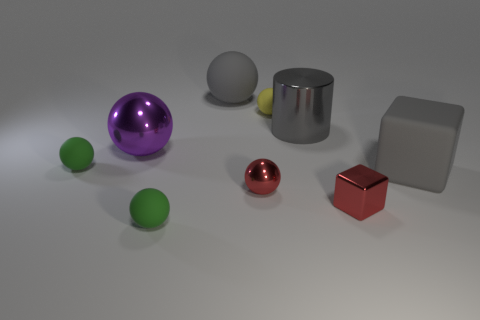There is a block that is the same color as the small metallic ball; what material is it?
Give a very brief answer. Metal. The matte sphere that is the same color as the metallic cylinder is what size?
Ensure brevity in your answer.  Large. Is the color of the tiny block the same as the rubber block?
Make the answer very short. No. What material is the gray object that is to the left of the red thing that is on the left side of the small red block?
Make the answer very short. Rubber. What size is the red sphere?
Give a very brief answer. Small. There is a gray cube that is the same material as the yellow thing; what size is it?
Offer a very short reply. Large. Is the size of the green rubber ball behind the shiny cube the same as the tiny metallic sphere?
Your answer should be very brief. Yes. There is a tiny green matte object that is in front of the small green matte thing behind the tiny matte sphere that is in front of the red shiny ball; what shape is it?
Your response must be concise. Sphere. How many things are either large gray matte balls or matte objects that are in front of the metallic cylinder?
Give a very brief answer. 4. There is a gray rubber thing that is left of the tiny yellow rubber thing; how big is it?
Your answer should be very brief. Large. 